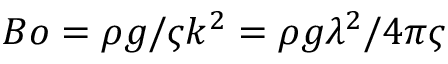Convert formula to latex. <formula><loc_0><loc_0><loc_500><loc_500>B o = \rho g / \varsigma k ^ { 2 } = \rho g \lambda ^ { 2 } / 4 \pi \varsigma</formula> 